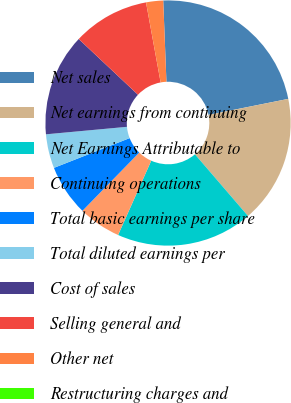Convert chart to OTSL. <chart><loc_0><loc_0><loc_500><loc_500><pie_chart><fcel>Net sales<fcel>Net earnings from continuing<fcel>Net Earnings Attributable to<fcel>Continuing operations<fcel>Total basic earnings per share<fcel>Total diluted earnings per<fcel>Cost of sales<fcel>Selling general and<fcel>Other net<fcel>Restructuring charges and<nl><fcel>22.47%<fcel>16.85%<fcel>17.98%<fcel>5.62%<fcel>6.74%<fcel>4.49%<fcel>13.48%<fcel>10.11%<fcel>2.25%<fcel>0.0%<nl></chart> 